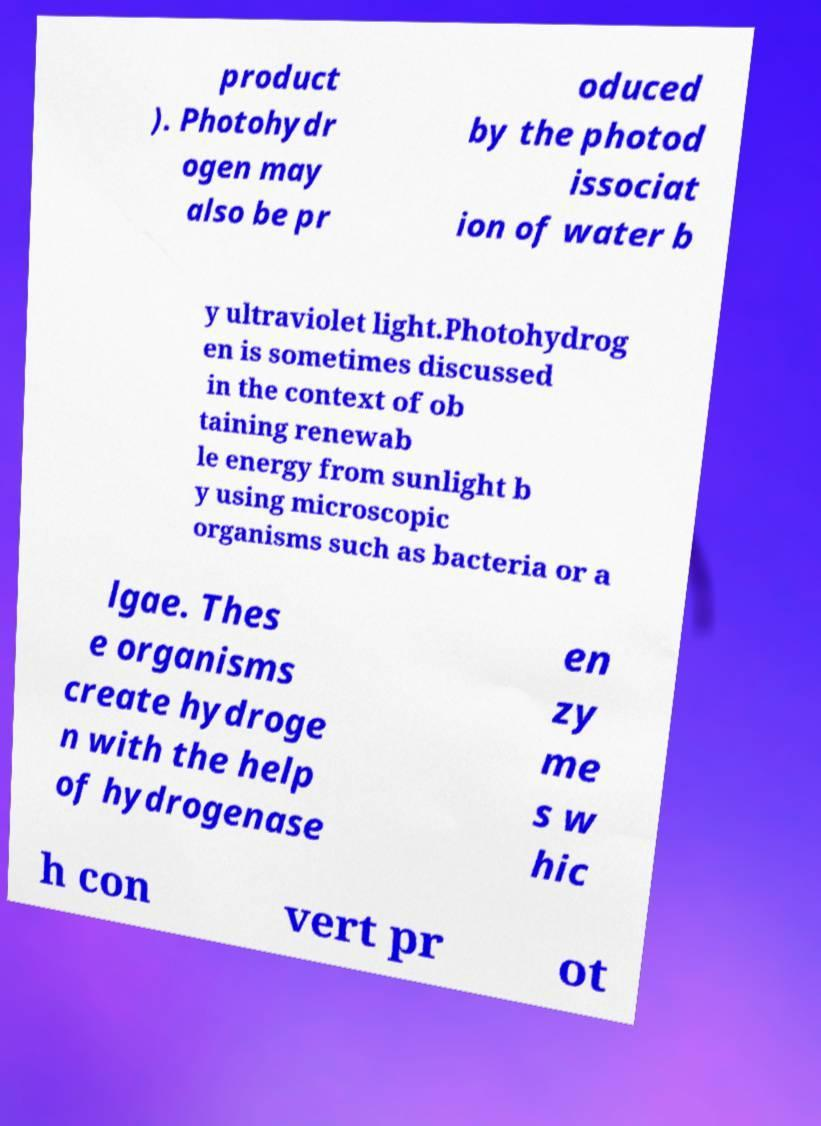Can you read and provide the text displayed in the image?This photo seems to have some interesting text. Can you extract and type it out for me? product ). Photohydr ogen may also be pr oduced by the photod issociat ion of water b y ultraviolet light.Photohydrog en is sometimes discussed in the context of ob taining renewab le energy from sunlight b y using microscopic organisms such as bacteria or a lgae. Thes e organisms create hydroge n with the help of hydrogenase en zy me s w hic h con vert pr ot 